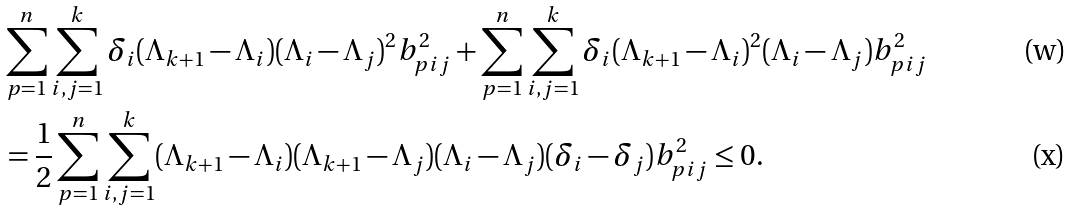Convert formula to latex. <formula><loc_0><loc_0><loc_500><loc_500>& \sum _ { p = 1 } ^ { n } \sum _ { i , j = 1 } ^ { k } \delta _ { i } ( \Lambda _ { k + 1 } - \Lambda _ { i } ) ( \Lambda _ { i } - \Lambda _ { j } ) ^ { 2 } b _ { p i j } ^ { 2 } + \sum _ { p = 1 } ^ { n } \sum _ { i , j = 1 } ^ { k } \delta _ { i } ( \Lambda _ { k + 1 } - \Lambda _ { i } ) ^ { 2 } ( \Lambda _ { i } - \Lambda _ { j } ) b _ { p i j } ^ { 2 } \\ & = \frac { 1 } { 2 } \sum _ { p = 1 } ^ { n } \sum _ { i , j = 1 } ^ { k } ( \Lambda _ { k + 1 } - \Lambda _ { i } ) ( \Lambda _ { k + 1 } - \Lambda _ { j } ) ( \Lambda _ { i } - \Lambda _ { j } ) ( \delta _ { i } - \delta _ { j } ) b _ { p i j } ^ { 2 } \leq 0 .</formula> 